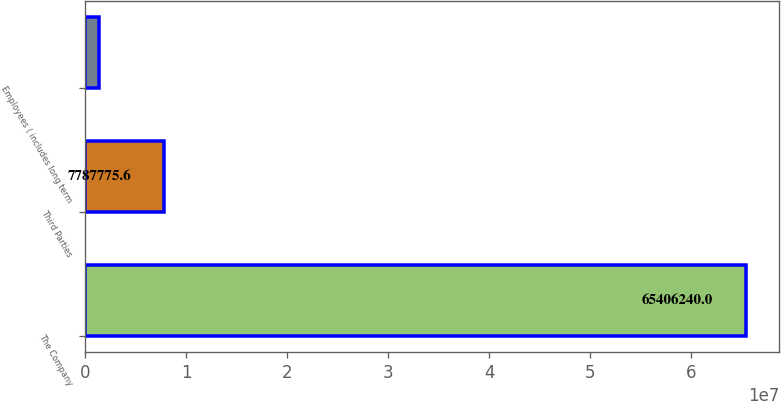Convert chart to OTSL. <chart><loc_0><loc_0><loc_500><loc_500><bar_chart><fcel>The Company<fcel>Third Parties<fcel>Employees ( includes long term<nl><fcel>6.54062e+07<fcel>7.78778e+06<fcel>1.38572e+06<nl></chart> 